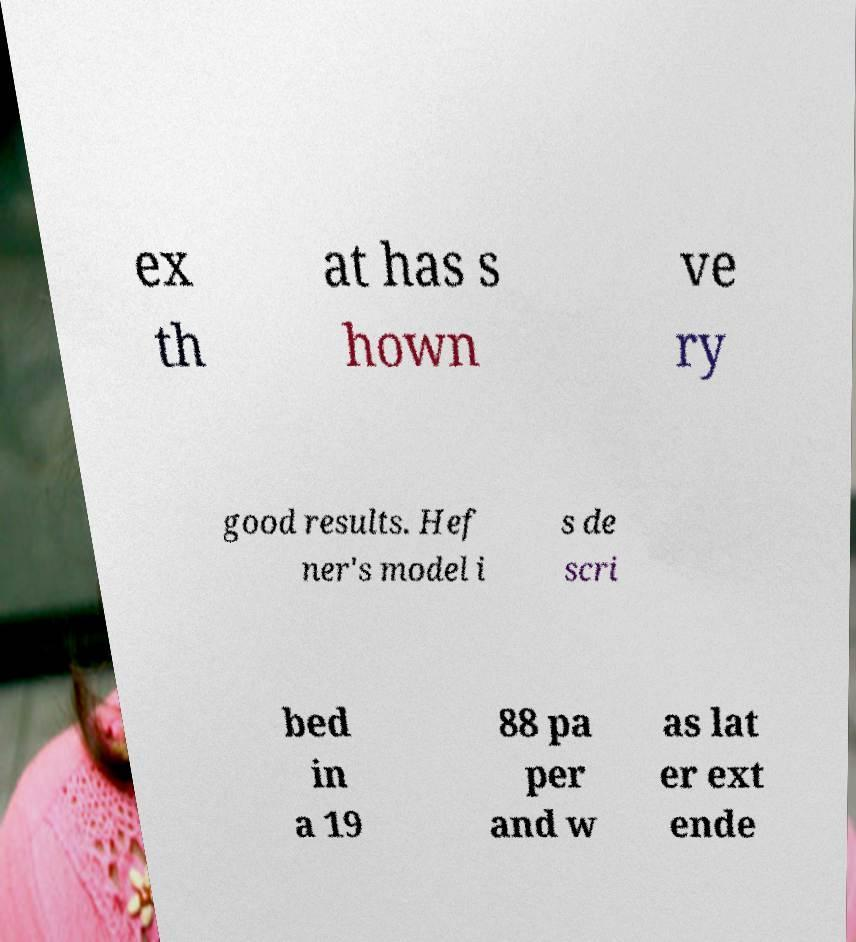Could you extract and type out the text from this image? ex th at has s hown ve ry good results. Hef ner's model i s de scri bed in a 19 88 pa per and w as lat er ext ende 